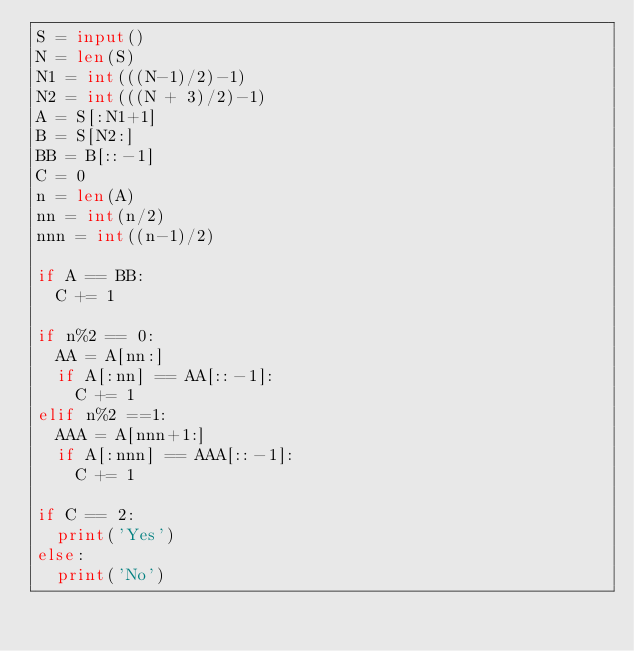Convert code to text. <code><loc_0><loc_0><loc_500><loc_500><_Python_>S = input()
N = len(S)
N1 = int(((N-1)/2)-1)
N2 = int(((N + 3)/2)-1)
A = S[:N1+1]
B = S[N2:]
BB = B[::-1]
C = 0
n = len(A)
nn = int(n/2)
nnn = int((n-1)/2)

if A == BB:
  C += 1
  
if n%2 == 0:
  AA = A[nn:]
  if A[:nn] == AA[::-1]:
    C += 1
elif n%2 ==1:
  AAA = A[nnn+1:]
  if A[:nnn] == AAA[::-1]:
    C += 1
    
if C == 2:
  print('Yes')
else:
  print('No')


</code> 